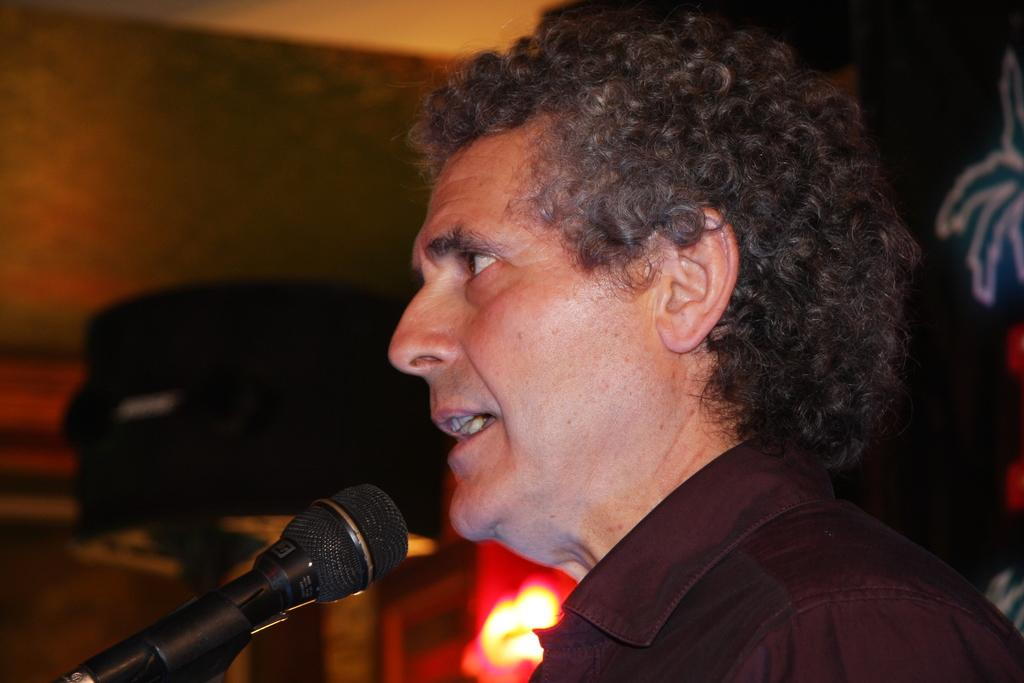Who is the main subject in the image? There is a man in the image. What is the man doing in the image? The man appears to be talking. What object is in front of the man? There is a microphone in front of the man. Can you describe the background of the image? The background of the man is blurred. What type of jellyfish can be seen swimming in the background of the image? There is no jellyfish present in the image; the background is blurred, but it does not show any aquatic life. 